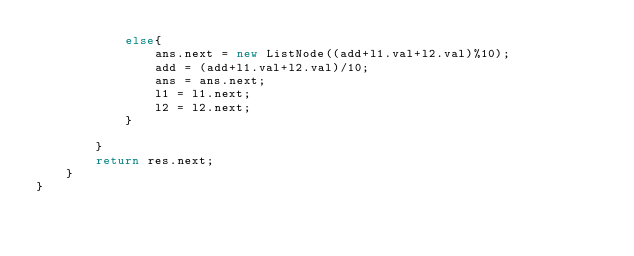<code> <loc_0><loc_0><loc_500><loc_500><_Java_>            else{
                ans.next = new ListNode((add+l1.val+l2.val)%10);
                add = (add+l1.val+l2.val)/10;
                ans = ans.next;
                l1 = l1.next;
                l2 = l2.next;
            }
                
        }
        return res.next;
    }
}</code> 